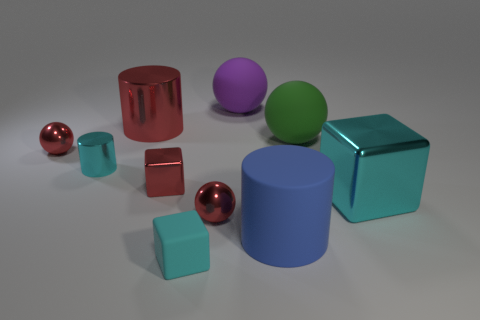Subtract all shiny blocks. How many blocks are left? 1 Subtract 1 cylinders. How many cylinders are left? 2 Subtract all yellow spheres. Subtract all yellow blocks. How many spheres are left? 4 Subtract 0 purple cylinders. How many objects are left? 10 Subtract all blocks. How many objects are left? 7 Subtract all matte balls. Subtract all large purple balls. How many objects are left? 7 Add 7 purple things. How many purple things are left? 8 Add 10 yellow rubber spheres. How many yellow rubber spheres exist? 10 